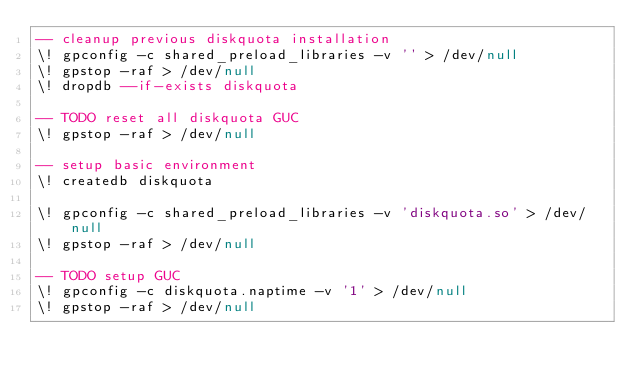Convert code to text. <code><loc_0><loc_0><loc_500><loc_500><_SQL_>-- cleanup previous diskquota installation
\! gpconfig -c shared_preload_libraries -v '' > /dev/null
\! gpstop -raf > /dev/null
\! dropdb --if-exists diskquota

-- TODO reset all diskquota GUC
\! gpstop -raf > /dev/null

-- setup basic environment
\! createdb diskquota

\! gpconfig -c shared_preload_libraries -v 'diskquota.so' > /dev/null
\! gpstop -raf > /dev/null

-- TODO setup GUC
\! gpconfig -c diskquota.naptime -v '1' > /dev/null
\! gpstop -raf > /dev/null
</code> 